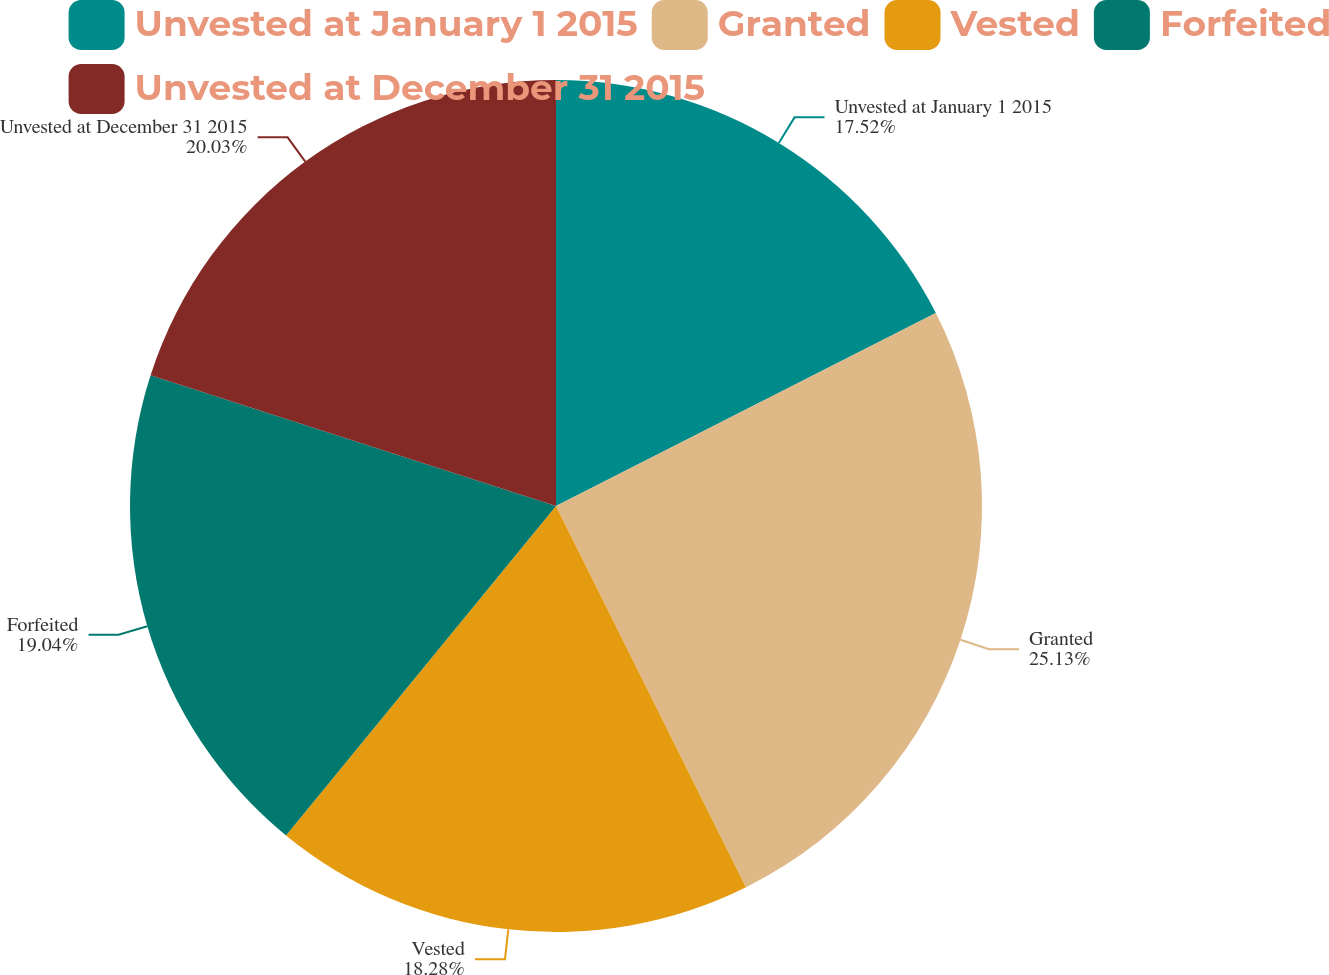Convert chart. <chart><loc_0><loc_0><loc_500><loc_500><pie_chart><fcel>Unvested at January 1 2015<fcel>Granted<fcel>Vested<fcel>Forfeited<fcel>Unvested at December 31 2015<nl><fcel>17.52%<fcel>25.12%<fcel>18.28%<fcel>19.04%<fcel>20.03%<nl></chart> 